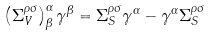<formula> <loc_0><loc_0><loc_500><loc_500>\left ( \Sigma _ { V } ^ { \rho \sigma } \right ) ^ { \alpha } _ { \beta } \gamma ^ { \beta } = \Sigma _ { S } ^ { \rho \sigma } \gamma ^ { \alpha } - \gamma ^ { \alpha } \Sigma _ { S } ^ { \rho \sigma }</formula> 